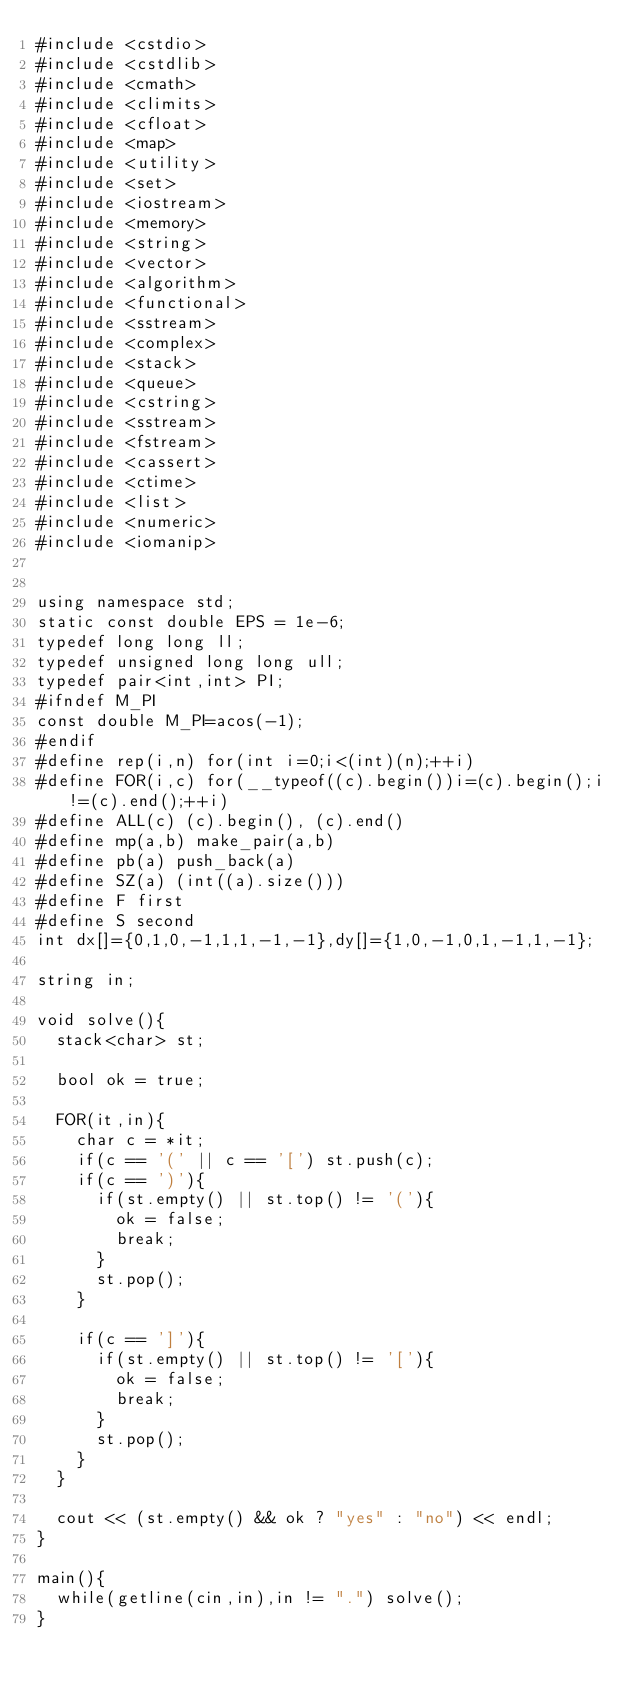<code> <loc_0><loc_0><loc_500><loc_500><_C++_>#include <cstdio>
#include <cstdlib>
#include <cmath>
#include <climits>
#include <cfloat>
#include <map>
#include <utility>
#include <set>
#include <iostream>
#include <memory>
#include <string>
#include <vector>
#include <algorithm>
#include <functional>
#include <sstream>
#include <complex>
#include <stack>
#include <queue>
#include <cstring>
#include <sstream>
#include <fstream>
#include <cassert>
#include <ctime>
#include <list>
#include <numeric>
#include <iomanip>


using namespace std;
static const double EPS = 1e-6;
typedef long long ll;
typedef unsigned long long ull;
typedef pair<int,int> PI;
#ifndef M_PI
const double M_PI=acos(-1);
#endif
#define rep(i,n) for(int i=0;i<(int)(n);++i)
#define FOR(i,c) for(__typeof((c).begin())i=(c).begin();i!=(c).end();++i)
#define ALL(c) (c).begin(), (c).end()
#define mp(a,b) make_pair(a,b)
#define pb(a) push_back(a)
#define SZ(a) (int((a).size()))
#define F first
#define S second
int dx[]={0,1,0,-1,1,1,-1,-1},dy[]={1,0,-1,0,1,-1,1,-1};

string in;

void solve(){
  stack<char> st;

  bool ok = true;

  FOR(it,in){
    char c = *it;
    if(c == '(' || c == '[') st.push(c);
    if(c == ')'){
      if(st.empty() || st.top() != '('){
        ok = false;
        break;
      }
      st.pop();
    }

    if(c == ']'){
      if(st.empty() || st.top() != '['){
        ok = false;
        break;
      }
      st.pop();
    }
  }

  cout << (st.empty() && ok ? "yes" : "no") << endl;
}

main(){
  while(getline(cin,in),in != ".") solve();
}</code> 